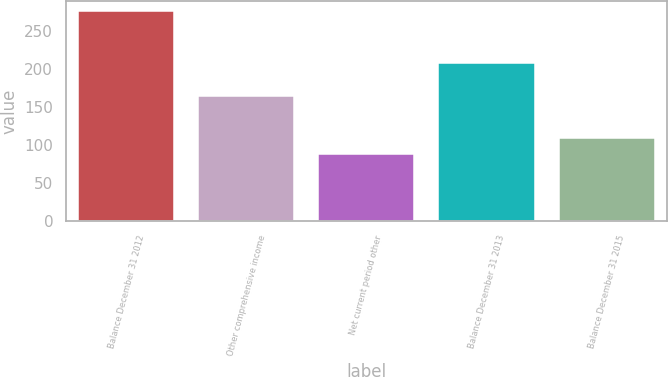<chart> <loc_0><loc_0><loc_500><loc_500><bar_chart><fcel>Balance December 31 2012<fcel>Other comprehensive income<fcel>Net current period other<fcel>Balance December 31 2013<fcel>Balance December 31 2015<nl><fcel>276<fcel>164<fcel>88.8<fcel>208<fcel>109.6<nl></chart> 